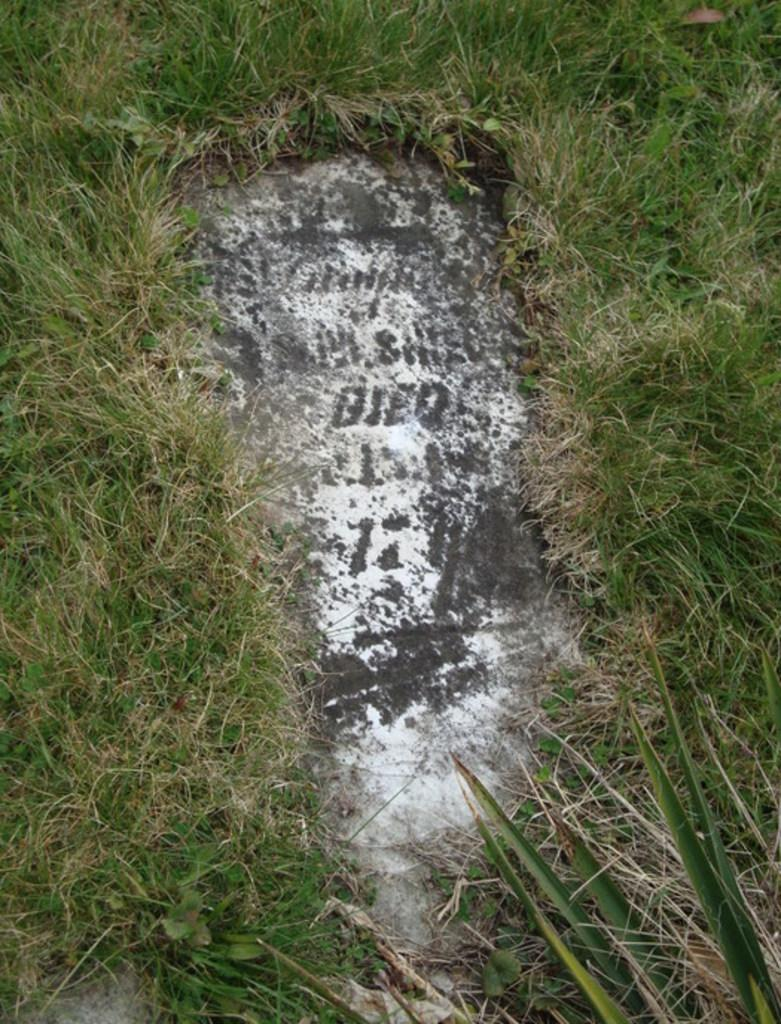What is the main structure in the image? There is a tomb in the image. What type of vegetation surrounds the tomb? The tomb is surrounded by grass. What type of joke is being told at the tomb in the image? There is no indication of a joke being told in the image; it simply shows a tomb surrounded by grass. 